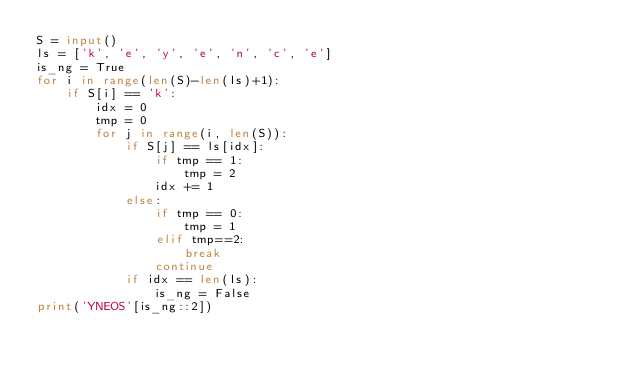<code> <loc_0><loc_0><loc_500><loc_500><_Python_>S = input()
ls = ['k', 'e', 'y', 'e', 'n', 'c', 'e']
is_ng = True
for i in range(len(S)-len(ls)+1):
    if S[i] == 'k':
        idx = 0
        tmp = 0
        for j in range(i, len(S)):
            if S[j] == ls[idx]:
                if tmp == 1:
                    tmp = 2
                idx += 1
            else:
                if tmp == 0:
                    tmp = 1
                elif tmp==2:
                    break
                continue
            if idx == len(ls):
                is_ng = False
print('YNEOS'[is_ng::2])</code> 